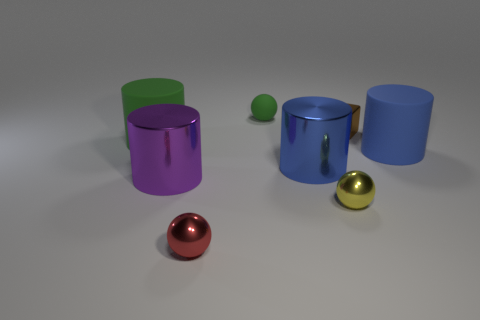What shape is the yellow object? The yellow object in the image is a small, perfectly shaped sphere, reminiscent of a polished ball used in various types of sports or as a decorative element. 